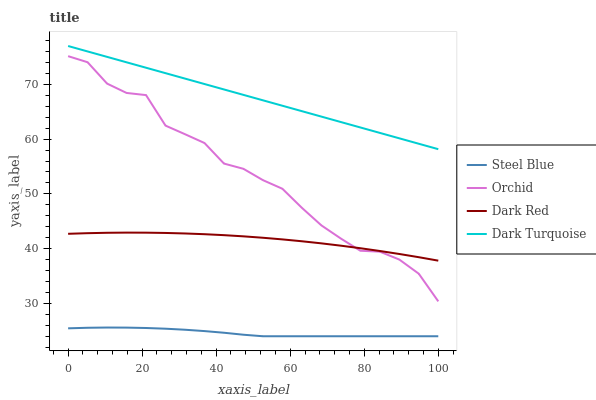Does Steel Blue have the minimum area under the curve?
Answer yes or no. Yes. Does Dark Turquoise have the maximum area under the curve?
Answer yes or no. Yes. Does Dark Turquoise have the minimum area under the curve?
Answer yes or no. No. Does Steel Blue have the maximum area under the curve?
Answer yes or no. No. Is Dark Turquoise the smoothest?
Answer yes or no. Yes. Is Orchid the roughest?
Answer yes or no. Yes. Is Steel Blue the smoothest?
Answer yes or no. No. Is Steel Blue the roughest?
Answer yes or no. No. Does Steel Blue have the lowest value?
Answer yes or no. Yes. Does Dark Turquoise have the lowest value?
Answer yes or no. No. Does Dark Turquoise have the highest value?
Answer yes or no. Yes. Does Steel Blue have the highest value?
Answer yes or no. No. Is Steel Blue less than Dark Red?
Answer yes or no. Yes. Is Dark Red greater than Steel Blue?
Answer yes or no. Yes. Does Dark Red intersect Orchid?
Answer yes or no. Yes. Is Dark Red less than Orchid?
Answer yes or no. No. Is Dark Red greater than Orchid?
Answer yes or no. No. Does Steel Blue intersect Dark Red?
Answer yes or no. No. 